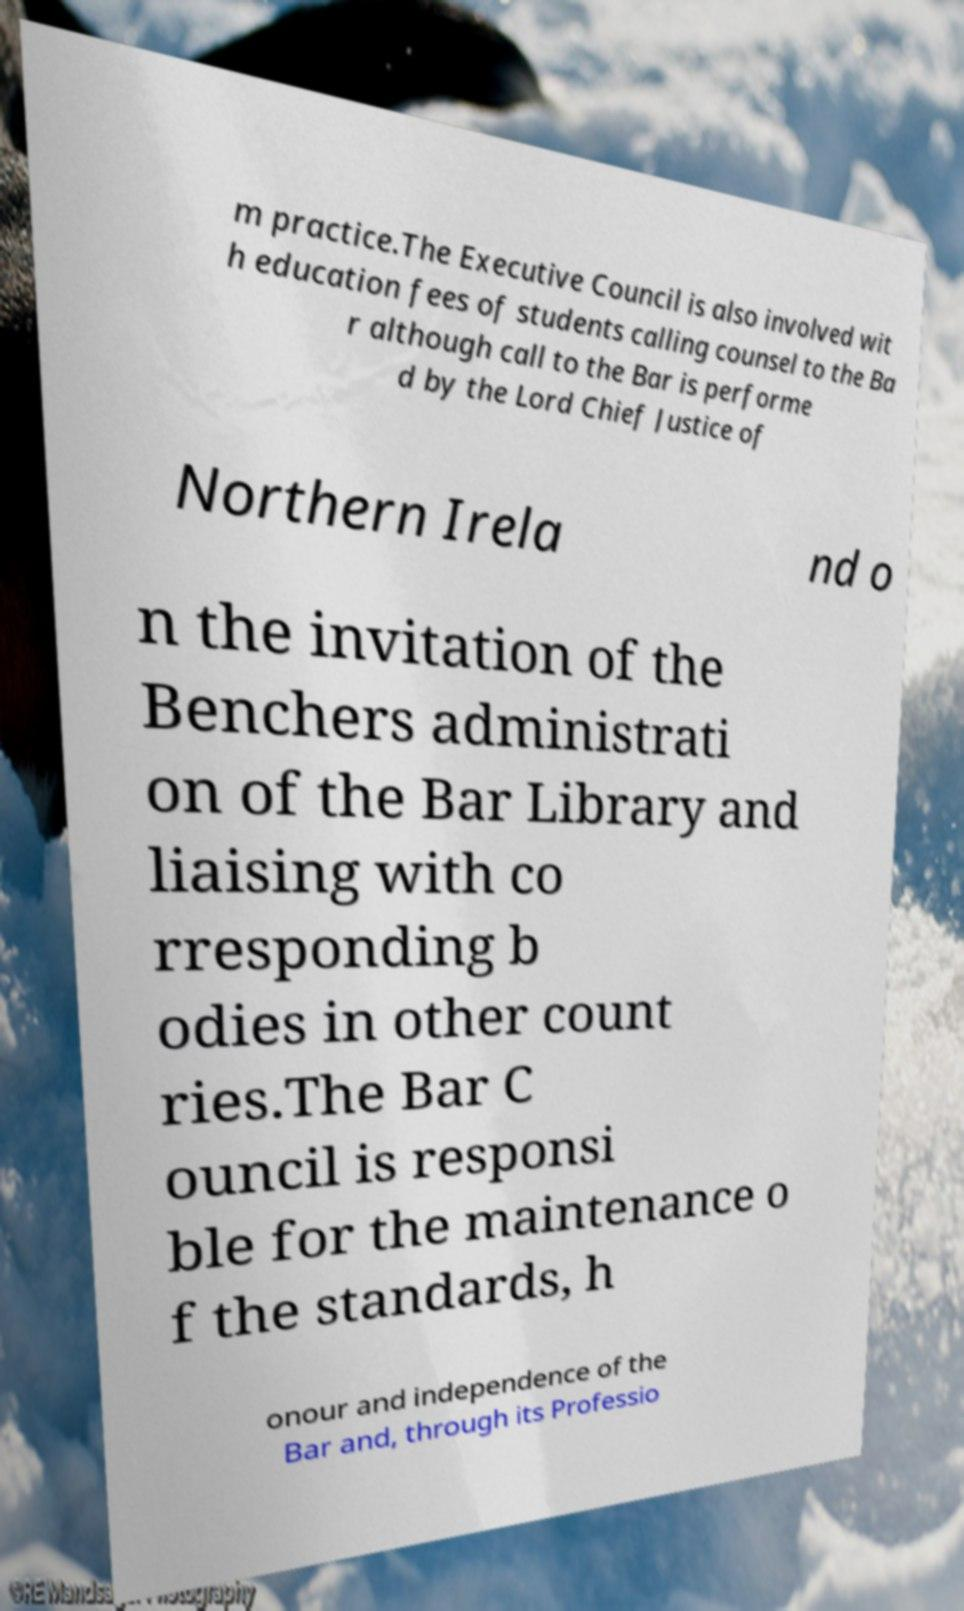Can you accurately transcribe the text from the provided image for me? m practice.The Executive Council is also involved wit h education fees of students calling counsel to the Ba r although call to the Bar is performe d by the Lord Chief Justice of Northern Irela nd o n the invitation of the Benchers administrati on of the Bar Library and liaising with co rresponding b odies in other count ries.The Bar C ouncil is responsi ble for the maintenance o f the standards, h onour and independence of the Bar and, through its Professio 